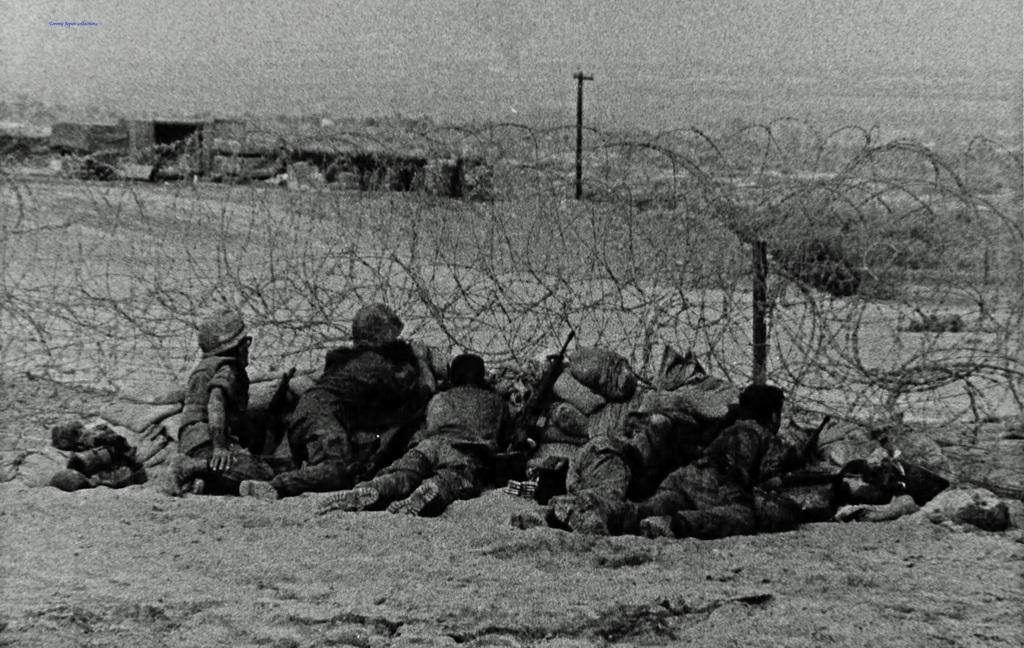Describe this image in one or two sentences. This is a black and white picture and in this picture we can see a group of people lying on the ground, guns, bags, fence, pole and some objects and in the background we can see the sky. 